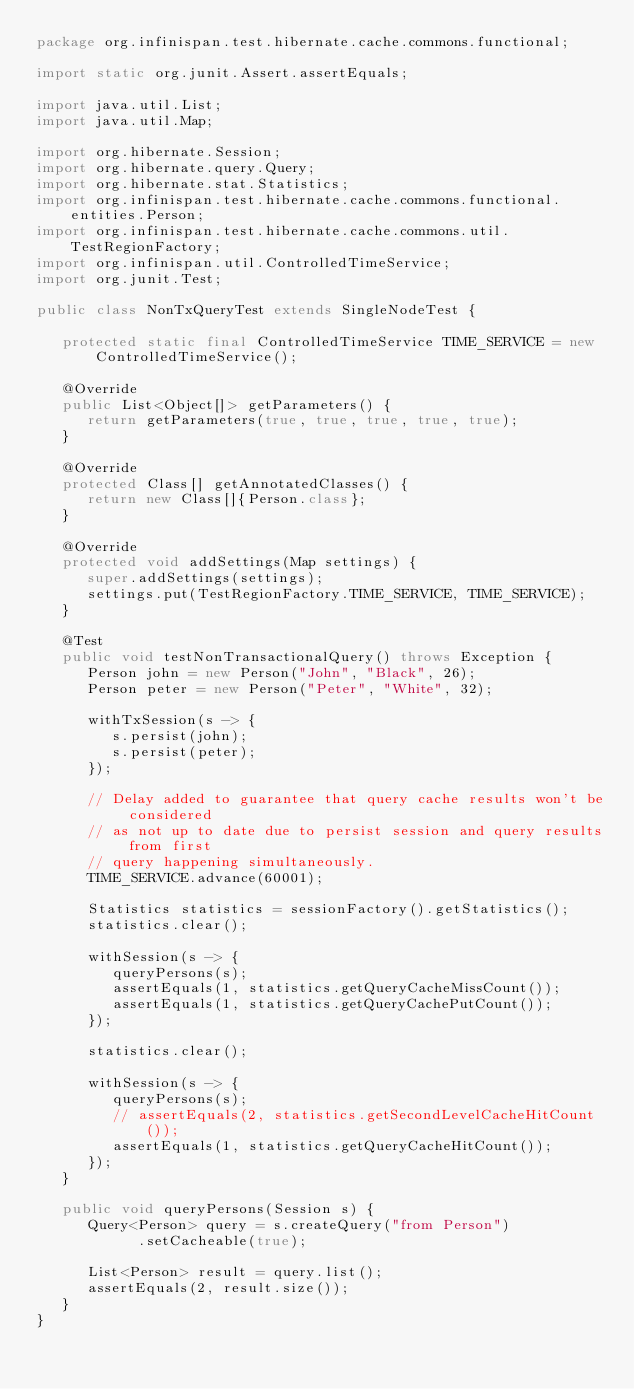Convert code to text. <code><loc_0><loc_0><loc_500><loc_500><_Java_>package org.infinispan.test.hibernate.cache.commons.functional;

import static org.junit.Assert.assertEquals;

import java.util.List;
import java.util.Map;

import org.hibernate.Session;
import org.hibernate.query.Query;
import org.hibernate.stat.Statistics;
import org.infinispan.test.hibernate.cache.commons.functional.entities.Person;
import org.infinispan.test.hibernate.cache.commons.util.TestRegionFactory;
import org.infinispan.util.ControlledTimeService;
import org.junit.Test;

public class NonTxQueryTest extends SingleNodeTest {

   protected static final ControlledTimeService TIME_SERVICE = new ControlledTimeService();

   @Override
   public List<Object[]> getParameters() {
      return getParameters(true, true, true, true, true);
   }

   @Override
   protected Class[] getAnnotatedClasses() {
      return new Class[]{Person.class};
   }

   @Override
   protected void addSettings(Map settings) {
      super.addSettings(settings);
      settings.put(TestRegionFactory.TIME_SERVICE, TIME_SERVICE);
   }

   @Test
   public void testNonTransactionalQuery() throws Exception {
      Person john = new Person("John", "Black", 26);
      Person peter = new Person("Peter", "White", 32);

      withTxSession(s -> {
         s.persist(john);
         s.persist(peter);
      });

      // Delay added to guarantee that query cache results won't be considered
      // as not up to date due to persist session and query results from first
      // query happening simultaneously.
      TIME_SERVICE.advance(60001);

      Statistics statistics = sessionFactory().getStatistics();
      statistics.clear();

      withSession(s -> {
         queryPersons(s);
         assertEquals(1, statistics.getQueryCacheMissCount());
         assertEquals(1, statistics.getQueryCachePutCount());
      });

      statistics.clear();

      withSession(s -> {
         queryPersons(s);
         // assertEquals(2, statistics.getSecondLevelCacheHitCount());
         assertEquals(1, statistics.getQueryCacheHitCount());
      });
   }

   public void queryPersons(Session s) {
      Query<Person> query = s.createQuery("from Person")
            .setCacheable(true);

      List<Person> result = query.list();
      assertEquals(2, result.size());
   }
}
</code> 